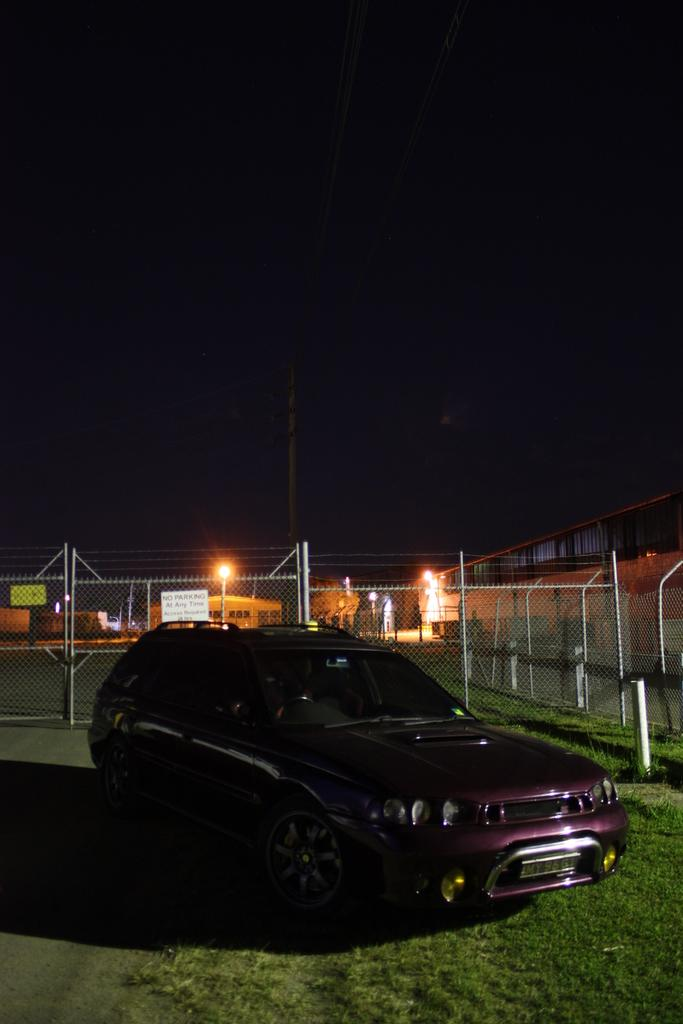Where is the car parked in the image? The car is parked on the grass in the image. What type of path can be seen in the image? There is a road in the image. What can be seen in the background of the image? In the background, there is a mesh, poles, boards, houses, street lights, and trees. How would you describe the lighting in the background of the image? The background has a dark view. What type of game is the group playing in the image? There is no group or game present in the image. 